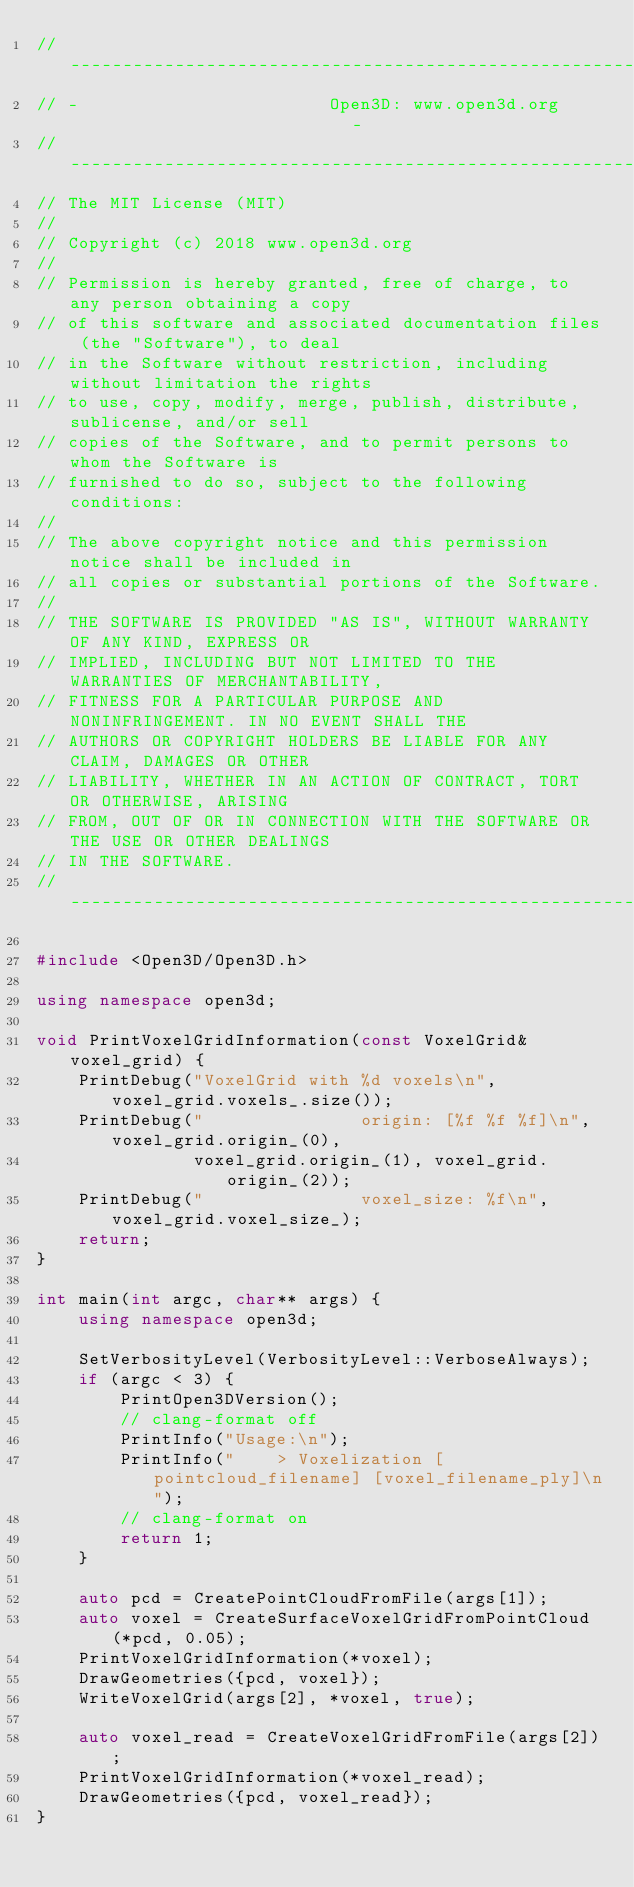<code> <loc_0><loc_0><loc_500><loc_500><_C++_>// ----------------------------------------------------------------------------
// -                        Open3D: www.open3d.org                            -
// ----------------------------------------------------------------------------
// The MIT License (MIT)
//
// Copyright (c) 2018 www.open3d.org
//
// Permission is hereby granted, free of charge, to any person obtaining a copy
// of this software and associated documentation files (the "Software"), to deal
// in the Software without restriction, including without limitation the rights
// to use, copy, modify, merge, publish, distribute, sublicense, and/or sell
// copies of the Software, and to permit persons to whom the Software is
// furnished to do so, subject to the following conditions:
//
// The above copyright notice and this permission notice shall be included in
// all copies or substantial portions of the Software.
//
// THE SOFTWARE IS PROVIDED "AS IS", WITHOUT WARRANTY OF ANY KIND, EXPRESS OR
// IMPLIED, INCLUDING BUT NOT LIMITED TO THE WARRANTIES OF MERCHANTABILITY,
// FITNESS FOR A PARTICULAR PURPOSE AND NONINFRINGEMENT. IN NO EVENT SHALL THE
// AUTHORS OR COPYRIGHT HOLDERS BE LIABLE FOR ANY CLAIM, DAMAGES OR OTHER
// LIABILITY, WHETHER IN AN ACTION OF CONTRACT, TORT OR OTHERWISE, ARISING
// FROM, OUT OF OR IN CONNECTION WITH THE SOFTWARE OR THE USE OR OTHER DEALINGS
// IN THE SOFTWARE.
// ----------------------------------------------------------------------------

#include <Open3D/Open3D.h>

using namespace open3d;

void PrintVoxelGridInformation(const VoxelGrid& voxel_grid) {
    PrintDebug("VoxelGrid with %d voxels\n", voxel_grid.voxels_.size());
    PrintDebug("               origin: [%f %f %f]\n", voxel_grid.origin_(0),
               voxel_grid.origin_(1), voxel_grid.origin_(2));
    PrintDebug("               voxel_size: %f\n", voxel_grid.voxel_size_);
    return;
}

int main(int argc, char** args) {
    using namespace open3d;

    SetVerbosityLevel(VerbosityLevel::VerboseAlways);
    if (argc < 3) {
        PrintOpen3DVersion();
        // clang-format off
        PrintInfo("Usage:\n");
        PrintInfo("    > Voxelization [pointcloud_filename] [voxel_filename_ply]\n");
        // clang-format on
        return 1;
    }

    auto pcd = CreatePointCloudFromFile(args[1]);
    auto voxel = CreateSurfaceVoxelGridFromPointCloud(*pcd, 0.05);
    PrintVoxelGridInformation(*voxel);
    DrawGeometries({pcd, voxel});
    WriteVoxelGrid(args[2], *voxel, true);

    auto voxel_read = CreateVoxelGridFromFile(args[2]);
    PrintVoxelGridInformation(*voxel_read);
    DrawGeometries({pcd, voxel_read});
}</code> 